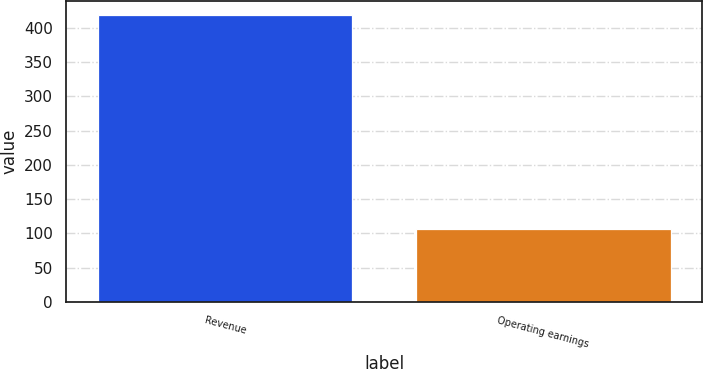Convert chart to OTSL. <chart><loc_0><loc_0><loc_500><loc_500><bar_chart><fcel>Revenue<fcel>Operating earnings<nl><fcel>419<fcel>106<nl></chart> 